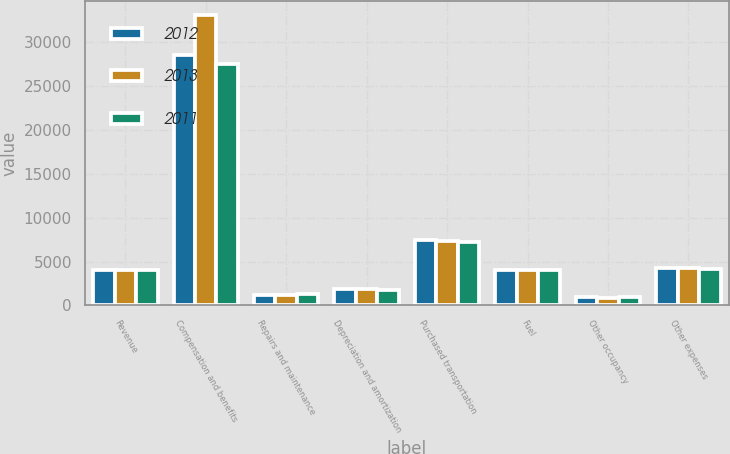Convert chart to OTSL. <chart><loc_0><loc_0><loc_500><loc_500><stacked_bar_chart><ecel><fcel>Revenue<fcel>Compensation and benefits<fcel>Repairs and maintenance<fcel>Depreciation and amortization<fcel>Purchased transportation<fcel>Fuel<fcel>Other occupancy<fcel>Other expenses<nl><fcel>2012<fcel>4046<fcel>28557<fcel>1240<fcel>1867<fcel>7486<fcel>4027<fcel>950<fcel>4277<nl><fcel>2013<fcel>4046<fcel>33102<fcel>1228<fcel>1858<fcel>7354<fcel>4090<fcel>902<fcel>4250<nl><fcel>2011<fcel>4046<fcel>27575<fcel>1286<fcel>1782<fcel>7232<fcel>4046<fcel>943<fcel>4161<nl></chart> 